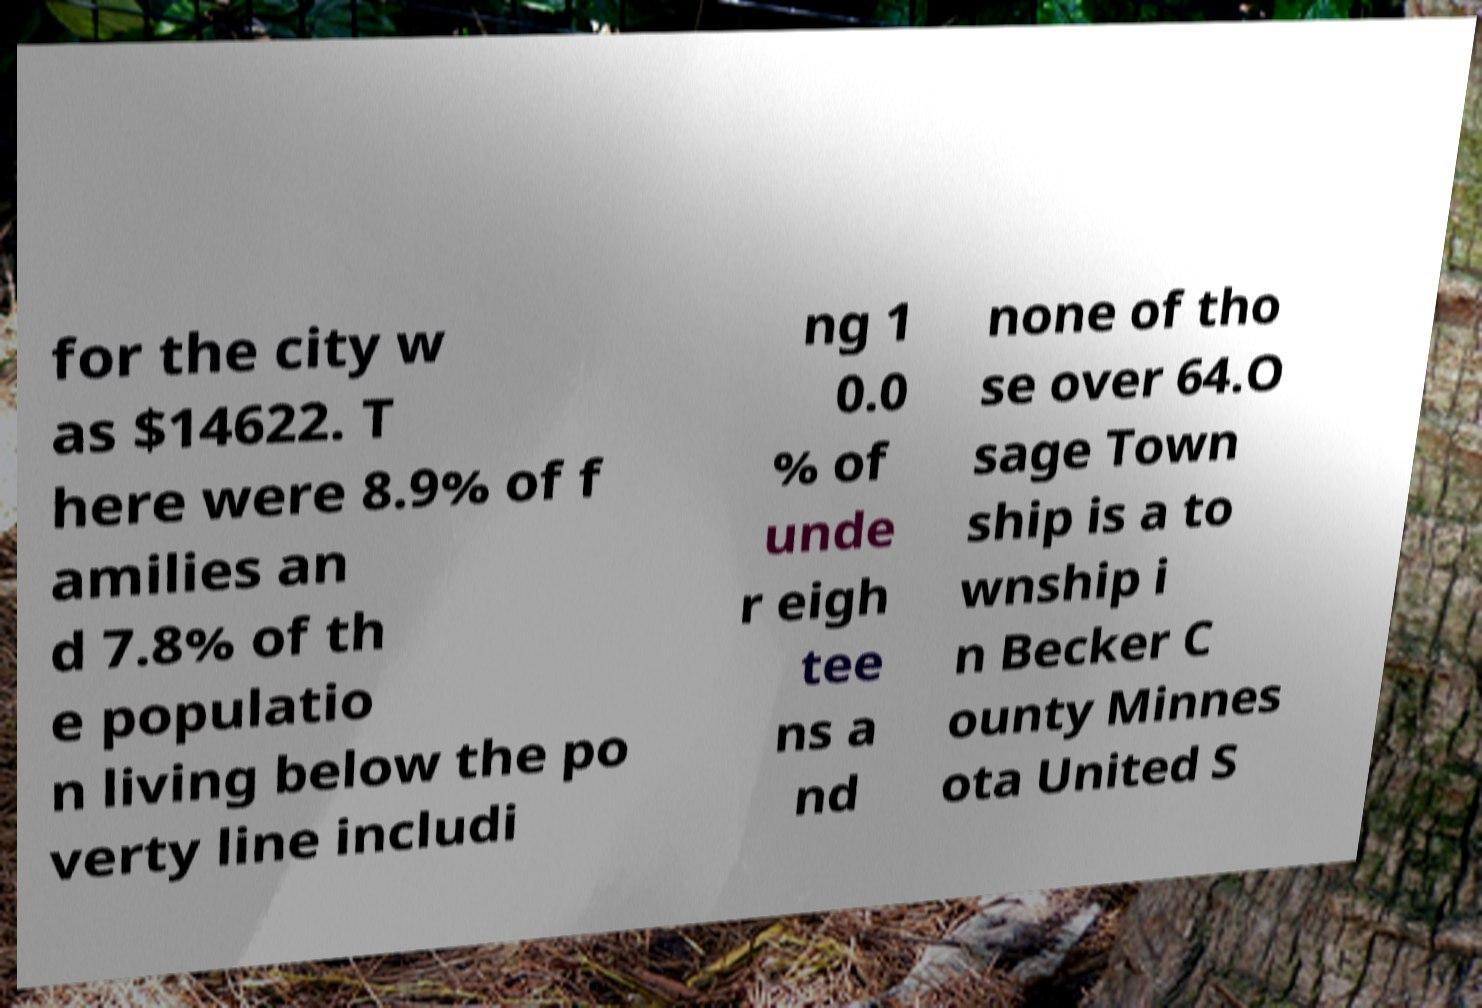Can you read and provide the text displayed in the image?This photo seems to have some interesting text. Can you extract and type it out for me? for the city w as $14622. T here were 8.9% of f amilies an d 7.8% of th e populatio n living below the po verty line includi ng 1 0.0 % of unde r eigh tee ns a nd none of tho se over 64.O sage Town ship is a to wnship i n Becker C ounty Minnes ota United S 